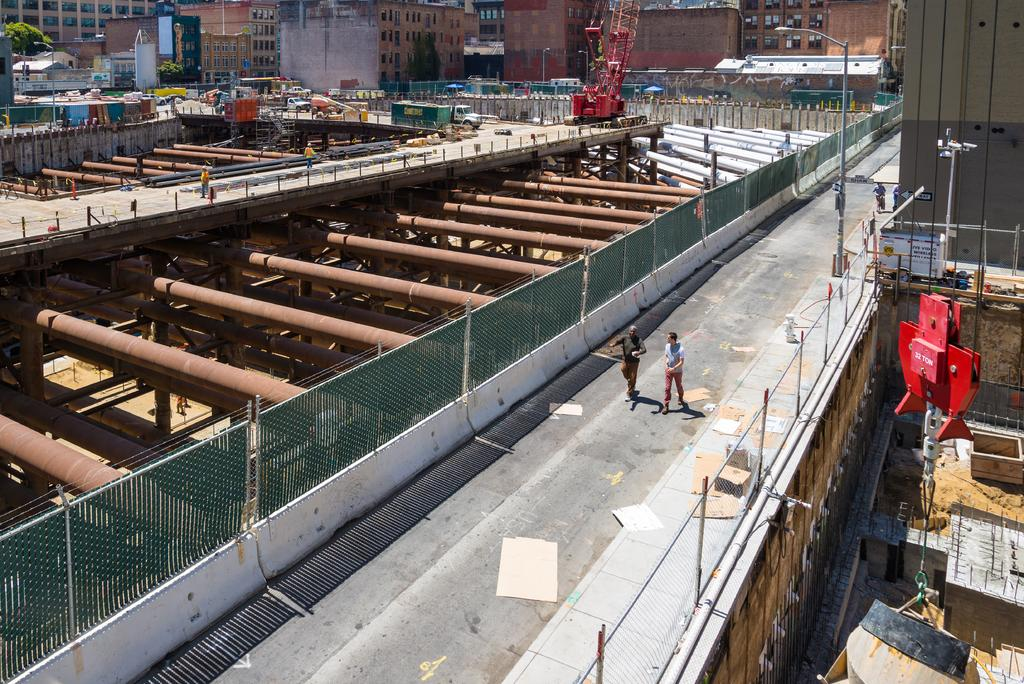What is the setting of the image? The image is taken in a construction zone. What are the two persons in the image doing? The two persons are walking on the road in the center of the image. What can be seen in the background of the image? There are buildings in the background of the image. Can you see a group of people forming a circle in the image? No, there is no group of people forming a circle in the image. 